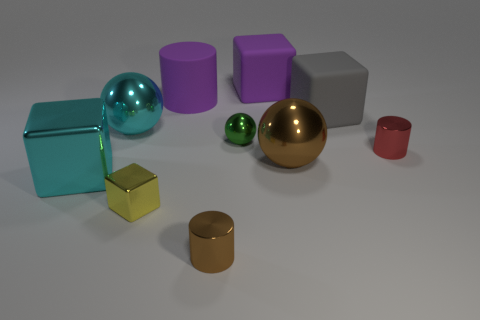Which objects in the image could reflect light well? The objects that would reflect light well are the two spheres, one teal and one green, as well as the golden and silver spheres due to their glossy finishes. 